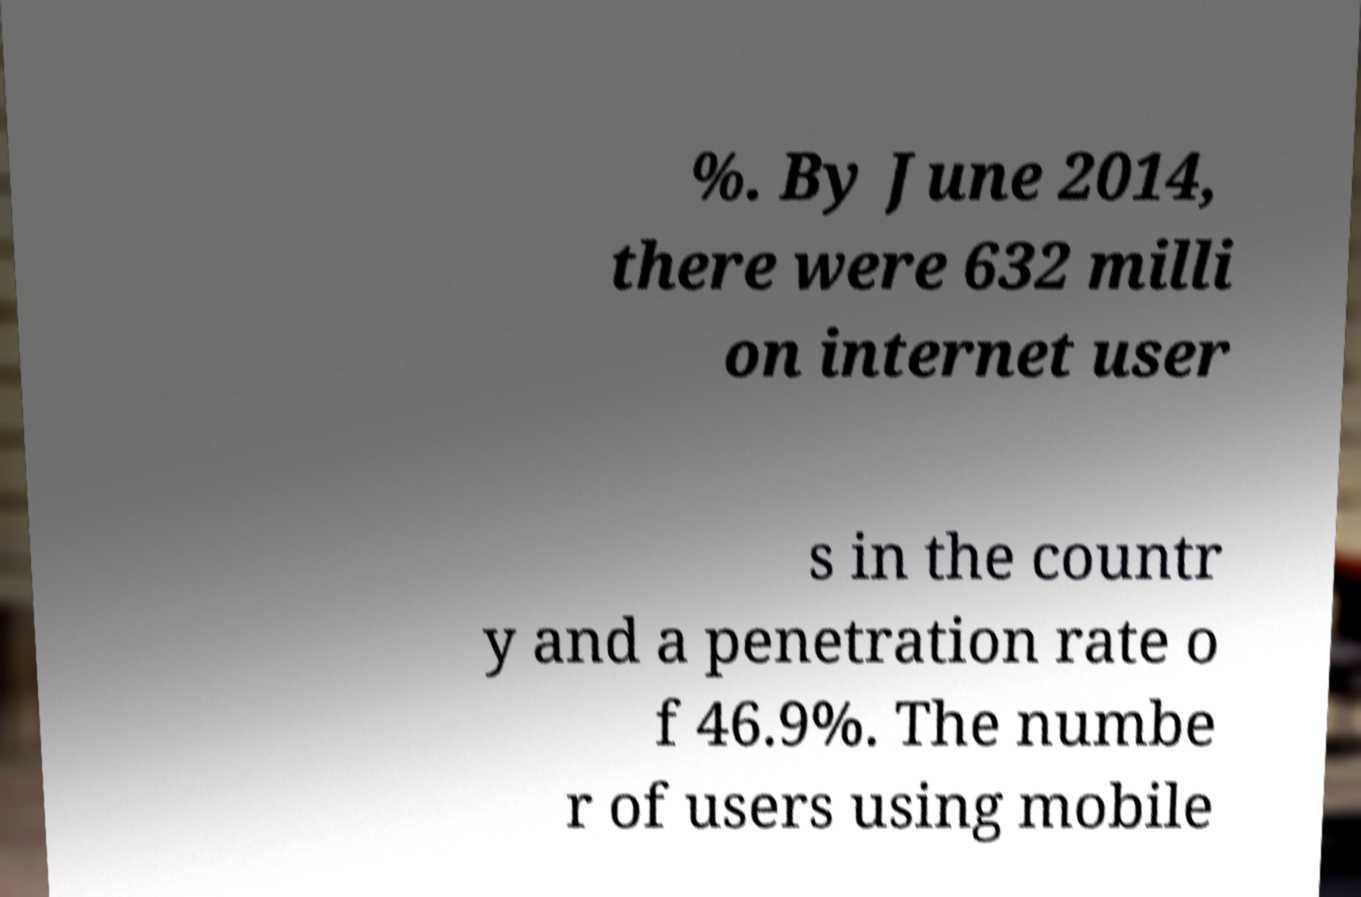I need the written content from this picture converted into text. Can you do that? %. By June 2014, there were 632 milli on internet user s in the countr y and a penetration rate o f 46.9%. The numbe r of users using mobile 